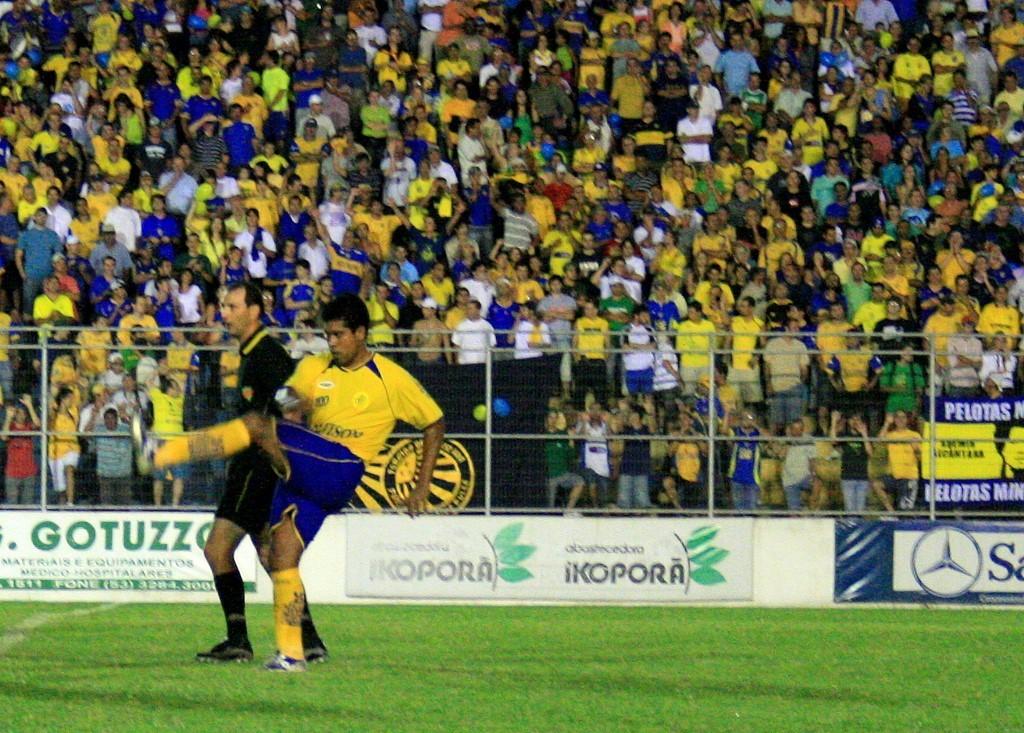What brand is on the banner in the middle?
Keep it short and to the point. Ikopora. 